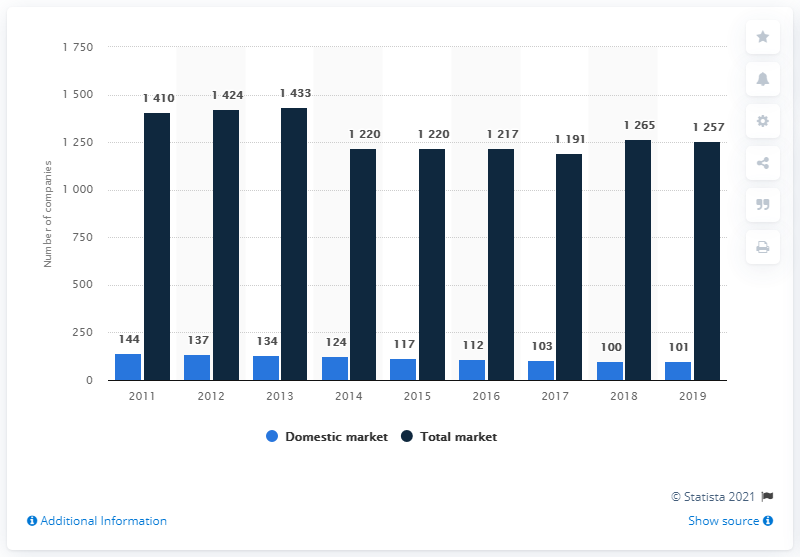Identify some key points in this picture. Of the companies operating on the Italian insurance market, 101 were domestic. As of December 2019, a total of 1191 companies were operating on the Italian insurance market. 